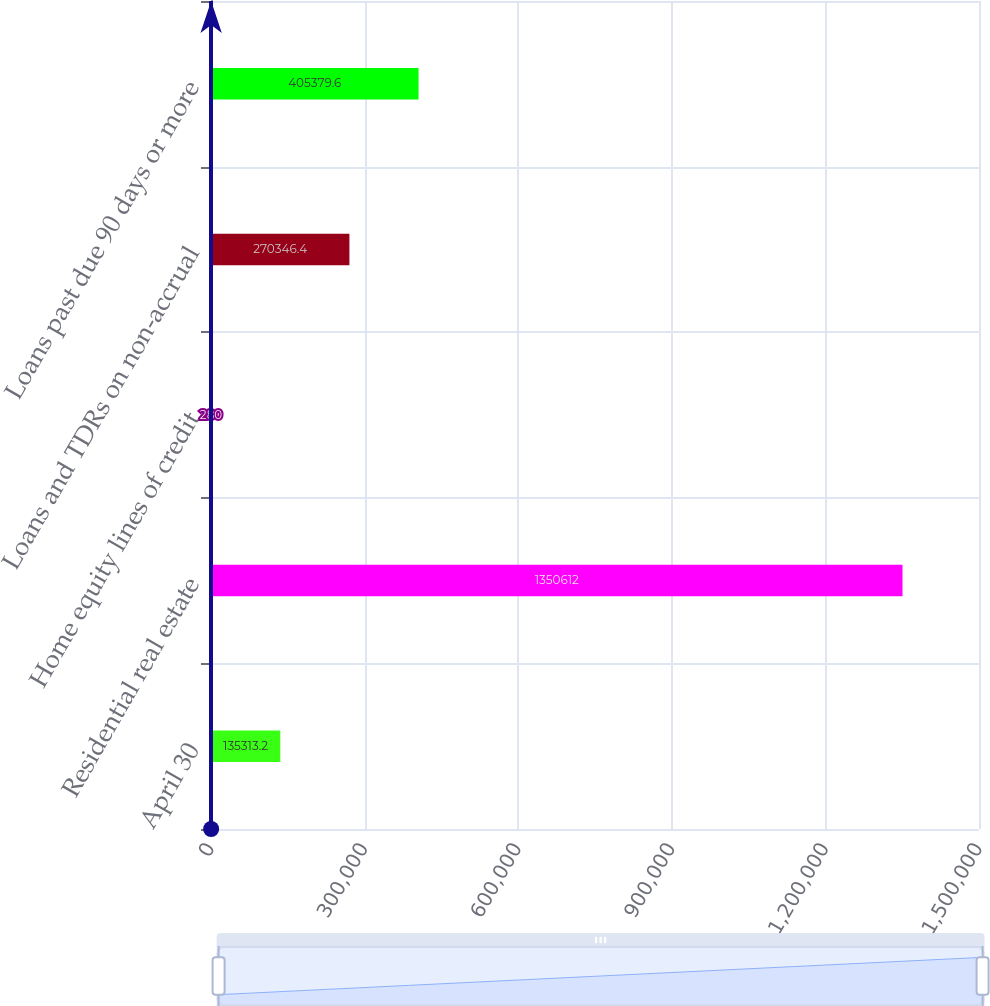Convert chart. <chart><loc_0><loc_0><loc_500><loc_500><bar_chart><fcel>April 30<fcel>Residential real estate<fcel>Home equity lines of credit<fcel>Loans and TDRs on non-accrual<fcel>Loans past due 90 days or more<nl><fcel>135313<fcel>1.35061e+06<fcel>280<fcel>270346<fcel>405380<nl></chart> 